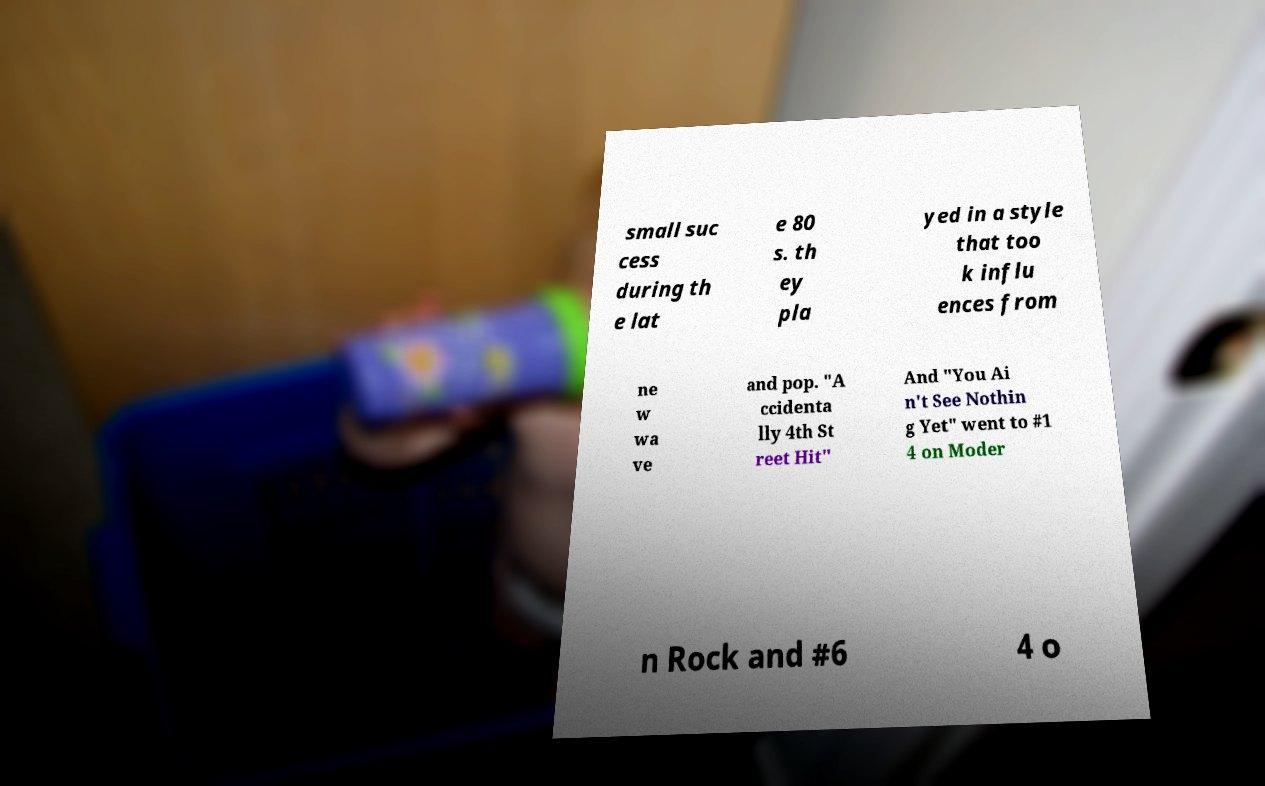There's text embedded in this image that I need extracted. Can you transcribe it verbatim? small suc cess during th e lat e 80 s. th ey pla yed in a style that too k influ ences from ne w wa ve and pop. "A ccidenta lly 4th St reet Hit" And "You Ai n't See Nothin g Yet" went to #1 4 on Moder n Rock and #6 4 o 